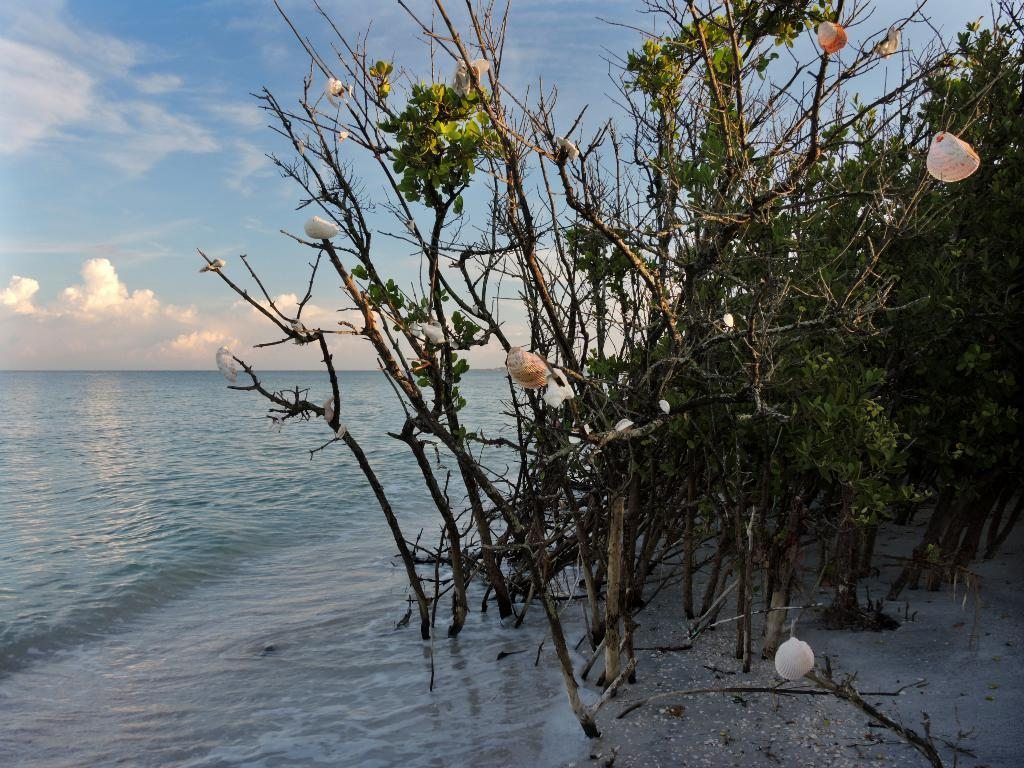What type of location is shown in the image? The image depicts a beach. What can be seen on the right side of the image? There are plants on the right side of the image. What is visible in the sky in the image? There are clouds visible in the sky. Can you tell me how many pigs are playing on the knee of the person in the image? There is no person or pig present in the image; it depicts a beach with plants and clouds. 